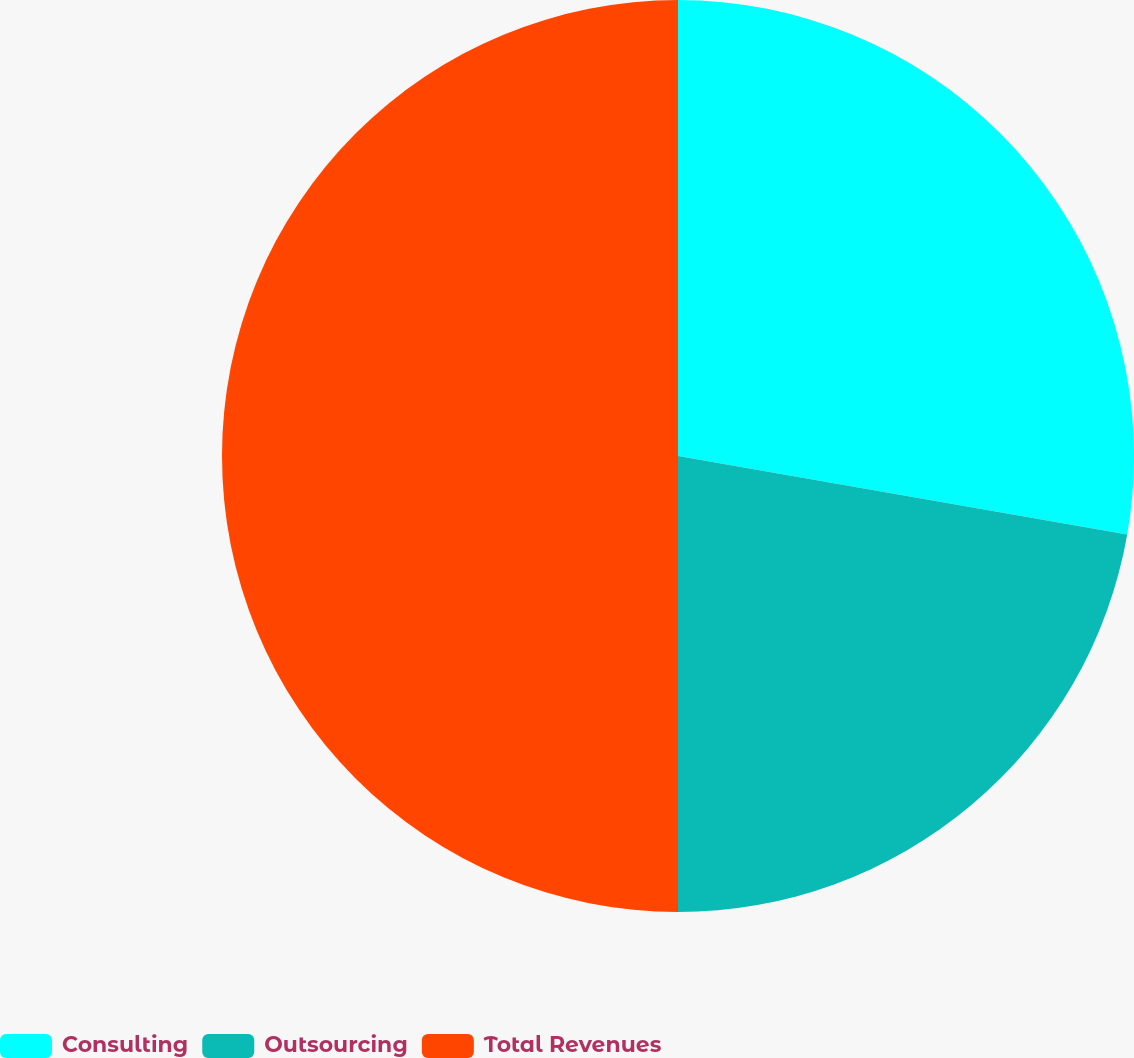Convert chart. <chart><loc_0><loc_0><loc_500><loc_500><pie_chart><fcel>Consulting<fcel>Outsourcing<fcel>Total Revenues<nl><fcel>27.75%<fcel>22.25%<fcel>50.0%<nl></chart> 